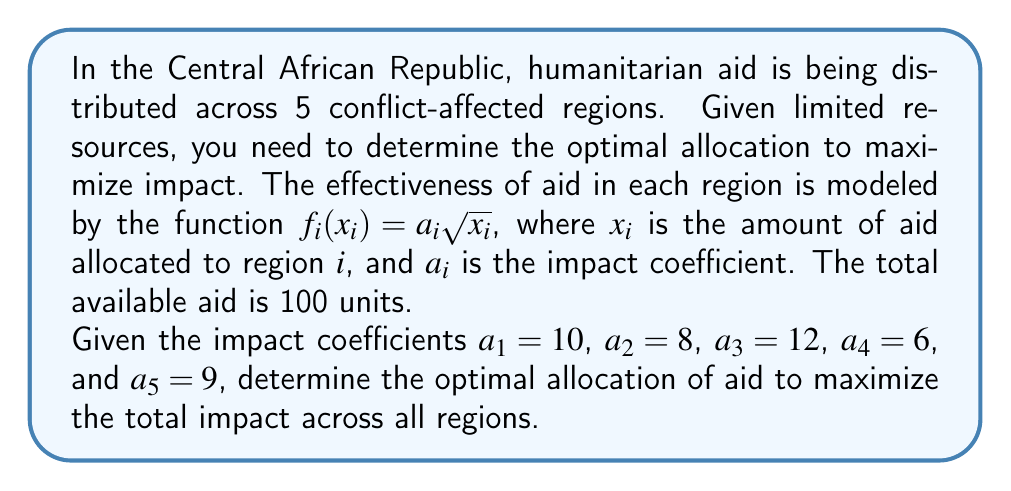Show me your answer to this math problem. To solve this inverse optimization problem, we'll follow these steps:

1) The objective is to maximize the total impact:
   $$\text{Maximize } \sum_{i=1}^5 f_i(x_i) = \sum_{i=1}^5 a_i\sqrt{x_i}$$

2) Subject to the constraint:
   $$\sum_{i=1}^5 x_i = 100$$

3) Using the method of Lagrange multipliers, we form the Lagrangian:
   $$L = \sum_{i=1}^5 a_i\sqrt{x_i} - \lambda(\sum_{i=1}^5 x_i - 100)$$

4) Taking partial derivatives and setting them to zero:
   $$\frac{\partial L}{\partial x_i} = \frac{a_i}{2\sqrt{x_i}} - \lambda = 0$$
   $$\frac{\partial L}{\partial \lambda} = \sum_{i=1}^5 x_i - 100 = 0$$

5) From the first equation:
   $$x_i = \frac{a_i^2}{4\lambda^2}$$

6) Substituting into the constraint:
   $$\sum_{i=1}^5 \frac{a_i^2}{4\lambda^2} = 100$$

7) Solving for $\lambda$:
   $$\lambda = \frac{\sqrt{\sum_{i=1}^5 a_i^2}}{20} = \frac{\sqrt{10^2 + 8^2 + 12^2 + 6^2 + 9^2}}{20} = \frac{\sqrt{469}}{20}$$

8) The optimal allocation for each region is:
   $$x_i = 100 \cdot \frac{a_i^2}{\sum_{j=1}^5 a_j^2}$$

9) Calculating the allocations:
   $$x_1 = 100 \cdot \frac{10^2}{469} \approx 21.32$$
   $$x_2 = 100 \cdot \frac{8^2}{469} \approx 13.65$$
   $$x_3 = 100 \cdot \frac{12^2}{469} \approx 30.70$$
   $$x_4 = 100 \cdot \frac{6^2}{469} \approx 7.68$$
   $$x_5 = 100 \cdot \frac{9^2}{469} \approx 17.27$$
Answer: $(21.32, 13.65, 30.70, 7.68, 17.27)$ 